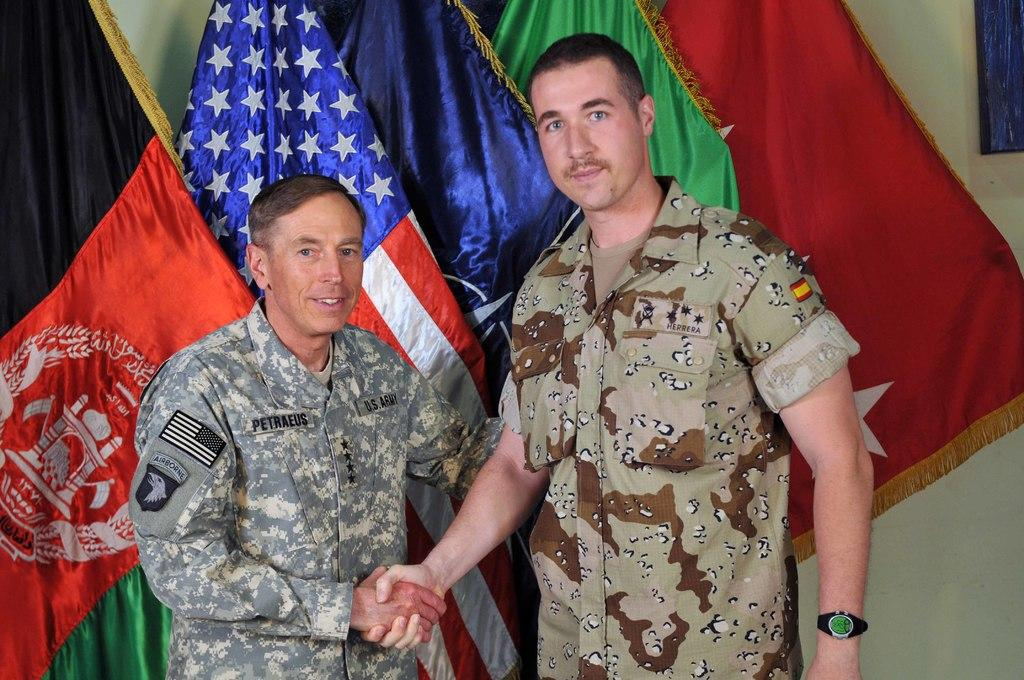<image>
Provide a brief description of the given image. Petraeus shakes hands with a man who is taller than him. 